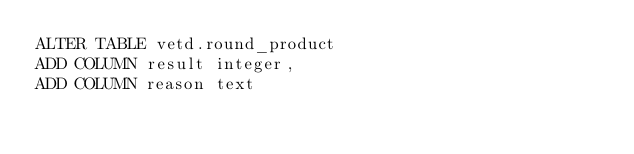Convert code to text. <code><loc_0><loc_0><loc_500><loc_500><_SQL_>ALTER TABLE vetd.round_product 
ADD COLUMN result integer,
ADD COLUMN reason text</code> 